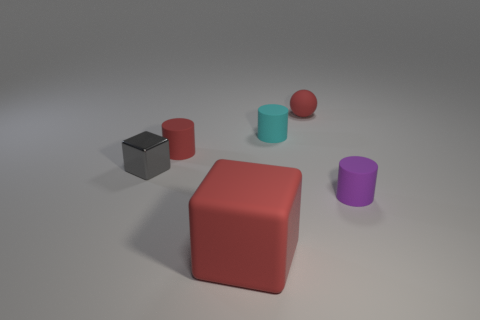Is there anything else that is made of the same material as the gray object?
Offer a terse response. No. Is there any other thing that is the same size as the rubber cube?
Your answer should be very brief. No. There is a small shiny thing; does it have the same shape as the red matte object in front of the small block?
Ensure brevity in your answer.  Yes. What material is the small purple cylinder?
Your response must be concise. Rubber. How many metallic objects are small blue spheres or blocks?
Provide a succinct answer. 1. Are there fewer gray metallic cubes that are left of the cyan rubber object than cylinders that are on the right side of the rubber block?
Keep it short and to the point. Yes. There is a red matte object behind the small red thing that is in front of the matte sphere; is there a tiny rubber cylinder left of it?
Provide a short and direct response. Yes. What is the material of the tiny sphere that is the same color as the large block?
Your response must be concise. Rubber. Does the red thing in front of the small purple cylinder have the same shape as the tiny metal thing that is to the left of the large rubber object?
Ensure brevity in your answer.  Yes. There is a purple object that is the same size as the cyan rubber thing; what is its material?
Your answer should be very brief. Rubber. 